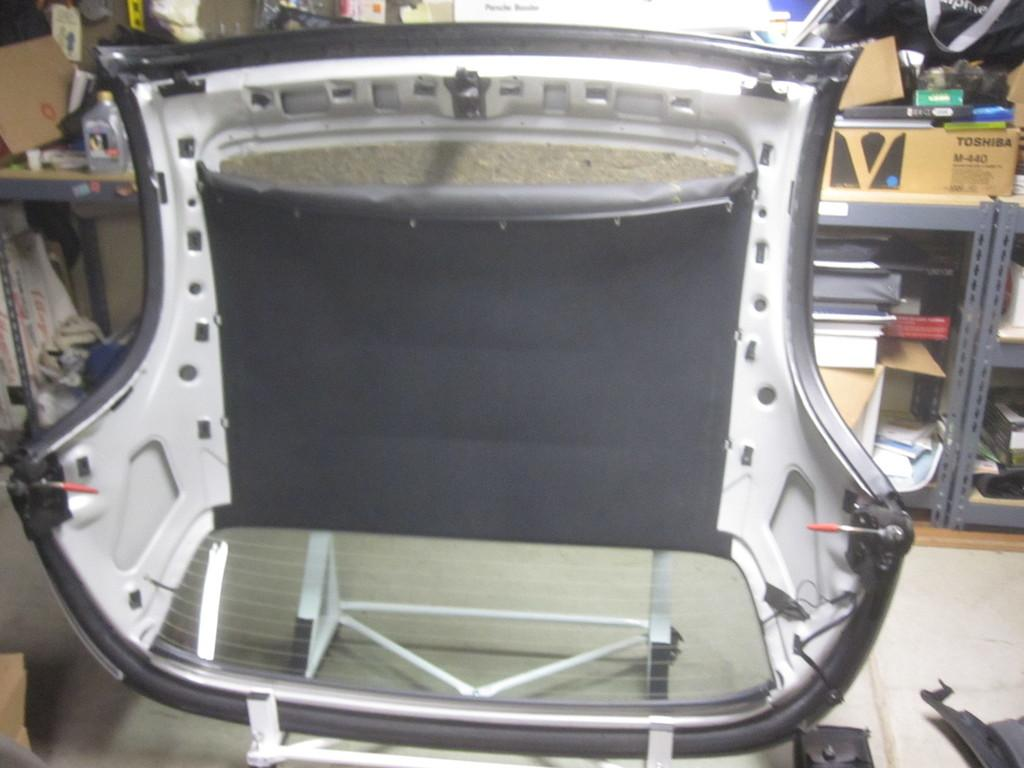What is placed on the floor in the image? There is a chair on the floor in the image. What can be seen in the background of the image? There are racks, books, and boxes in the background of the image. Are there any other objects visible in the background? Yes, there are other objects visible in the background of the image. What type of rain can be seen falling from the ceiling in the image? There is no rain present in the image; it is an indoor setting with a chair, racks, books, boxes, and other objects. 